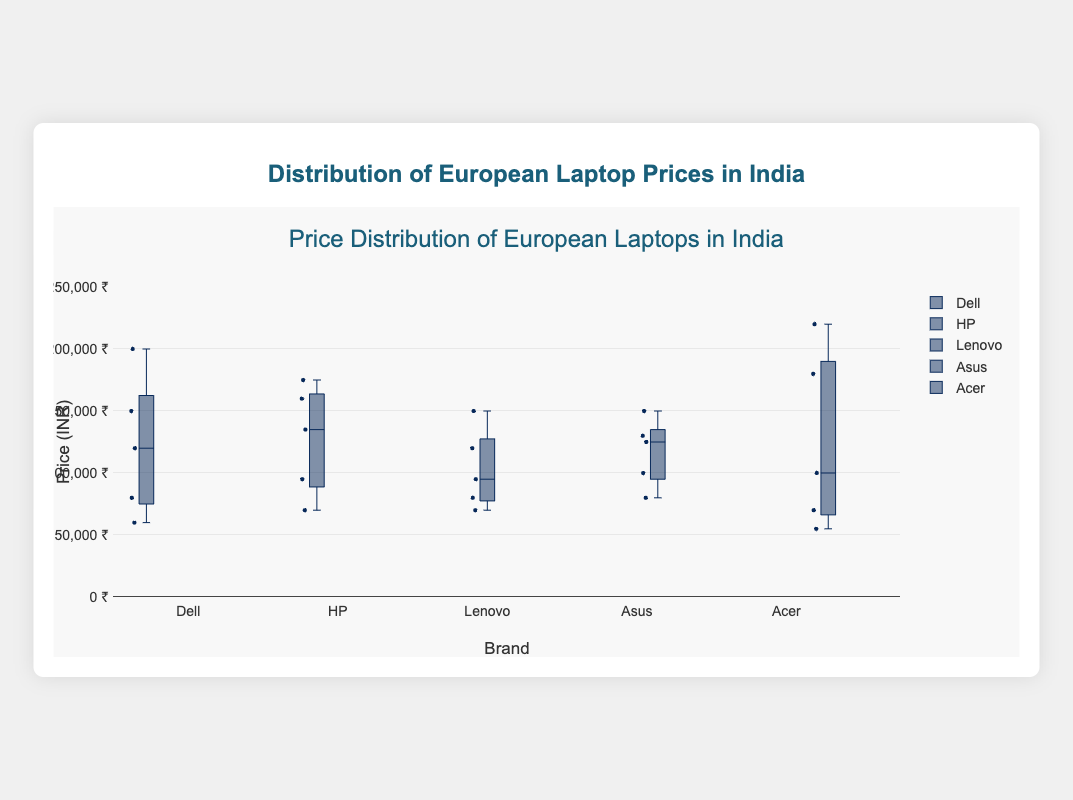Which brand has the highest maximum price? Look at the highest point of each box plot. The tallest plot indicates the brand with the highest maximum price. Acer's box plot reaches the highest with the ConceptD 7 model priced at 220,000 INR.
Answer: Acer What is the range of prices for Dell laptops? The range is determined by the difference between the highest and lowest prices in Dell's box plot. The highest price is 200,000 INR (Alienware M15), and the lowest is 60,000 INR (Inspiron 14). So, the range is 200,000 - 60,000.
Answer: 140,000 INR Which brand has the largest interquartile range (IQR)? The IQR is the difference between the third quartile (Q3) and the first quartile (Q1). Examine which box plot has the widest section between its Q1 and Q3 that forms the box. It looks to be HP, with a spread encompassing prices from roughly 70,000 to 160,000 INR.
Answer: HP What is the median price of Lenovo laptops? The median price is shown by the line within Lenovo's box plot. The line for Lenovo is at the 95,000 INR mark.
Answer: 95,000 INR How many laptop models does each brand have represented? Each dot on the box plot represents a data point. Seeing the number of individual points under each brand's name will give the count of models. Each brand has 5 laptop models, verified by counting the data points (dots) for each brand.
Answer: 5 models each Which brand has the most consistent pricing? The consistency of pricing can be observed by the box plot whose whiskers and box are the smallest and most compressed. The brand with the smallest range and less spread is Lenovo.
Answer: Lenovo Among the plotted brands, which one has the lowest minimum price? Look at the lowest point of each box plot. The lowest point on the plots is Acer with its model Aspire 5 priced at 55,000 INR.
Answer: Acer What is the median value for HP laptops, and how does it compare to Asus? The median value for HP is at the line within HP's box plot at 135,000 INR. Compare it to Asus, which has a median line at 125,000 INR.
Answer: HP's median is 135,000 INR; Asus's median is 125,000 INR Which brand has the greatest price range between its lower and upper whiskers? To find the greatest range, look at the difference from the lowest to the highest point (whiskers) in the box plots. Acer has the largest span from the lowest whisker at 55,000 INR to the highest at 220,000 INR.
Answer: Acer 